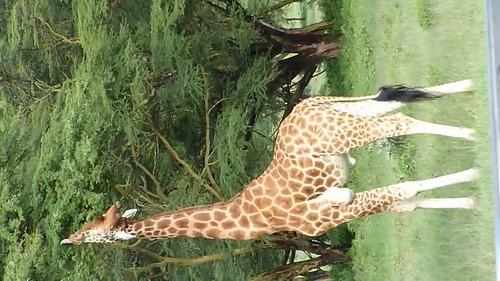Describe an action the giraffe is doing in the image. The giraffe is sticking out its tongue. Analyze the interaction between the giraffe and its environment. The giraffe is eating from a tree, sticking out its tongue, and surrounded by green trees and grass, indicating a healthy and natural interaction. How many ears of the giraffe are image detecting? There are two image describing the giraffe's ears. What is the color of the giraffe's legs? The giraffe's legs are white. What is the pattern found on the giraffe? The pattern on the giraffe is spotted. Count the number of giraffe legs that are being detected with image. The image detect six giraffe legs. What is the sentiment conveyed by the image of the giraffe? The sentiment is positive and joyful, as the giraffe is interacting with its environment. Identify the objects and colors in the image. Objects include a brown and white giraffe, green grass, green trees, brown trunk, and green leaves. What type of tree is present in the image? A large tree trunk with green, leafy branches. Is the giraffe eating from a tree in the image? No Which of these captions best describes the image: "a giraffe in the wild", "a cat with a long tail", "a happy cow", or "an elephant with big ears"? a giraffe in the wild What is the color and pattern on the giraffe's body? Brown and white, with a spotted pattern Write a creative caption for the image. A majestic giraffe with a cheeky grin explores its natural habitat. Did you notice the giraffe with a short neck in the image? No, it's not mentioned in the image. How would you describe the ears of the giraffe? The ears are oval-shaped and located near the top of its head. What type of trees can be seen in the background? Green and leafy trees Describe the overall scene depicted in the image. A brown and white giraffe with a spotted pattern is in a wild setting, surrounded by green trees and grass, sticking out its tongue. How would you describe the pattern of the giraffe's spots? The spots have a brown color and an irregular shape. Describe the appearance of the tree trunk. The tree trunk is large, brown, and thick. Describe the main features of the giraffe's head. The giraffe has a long neck, brown ossicles, ears, and its tongue is sticking out. Comment on the presence of any branches in the image. There are branches in the tree with green leaves. What is the main animal in the image? Giraffe What is the overall setting of the image? A wild natural habitat with a giraffe, green trees, and grass. Is there a blue spotted pattern on the giraffe? There is a spotted pattern on the giraffe, but its color is not mentioned. By asking about a blue spotted pattern, we may confuse the viewer, as that specific color is not present in the information given. Explain the position of the giraffe's front and back legs. The front legs are closer to the head, while the back legs are closer to the tail. What is the condition of the grass on the ground? The grass is green and tall. Does the giraffe have its tongue sticking out? Yes What color is the giraffe's tail, and does it have a pattern? The tail is black and brown without a distinct pattern. Comment on the trunk of the tree in the image. The tree trunk is large and brown. 